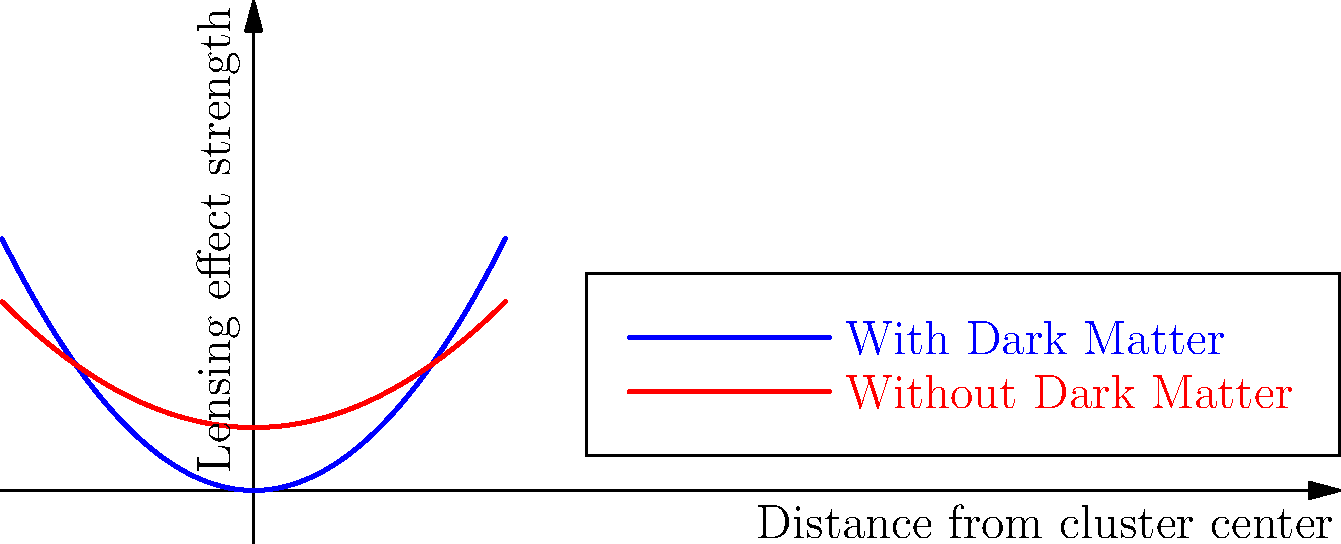Based on the graph showing gravitational lensing effects in galaxy clusters with and without dark matter assumptions, which model predicts a stronger lensing effect at greater distances from the cluster center, and how does this challenge the conventional dark matter paradigm? To answer this question, let's analyze the graph step-by-step:

1. The blue curve represents the lensing effect with dark matter assumptions, while the red curve represents the effect without dark matter.

2. Both curves show an increase in lensing effect strength as we move away from the cluster center (x-axis).

3. The blue curve (with dark matter) shows a steeper increase compared to the red curve (without dark matter).

4. At greater distances from the cluster center, the blue curve predicts a stronger lensing effect than the red curve.

5. This observation aligns with the conventional dark matter paradigm, which suggests that dark matter contributes significantly to the total mass of galaxy clusters, thereby enhancing gravitational lensing effects.

6. However, the presence of a lensing effect in the model without dark matter (red curve) challenges the notion that dark matter is necessary to explain gravitational lensing in galaxy clusters.

7. The red curve suggests that alternative theories or modifications to gravity might explain observed lensing effects without invoking dark matter.

8. The difference between the two curves is not as dramatic as one might expect if dark matter were the dominant factor in gravitational lensing.

This graph challenges the conventional dark matter paradigm by showing that:
a) Lensing effects can be observed without dark matter assumptions.
b) The difference in lensing strength between models with and without dark matter is less pronounced than expected.
c) Alternative explanations for gravitational lensing effects in galaxy clusters may be viable.
Answer: The dark matter model predicts stronger lensing at greater distances, but the presence of lensing without dark matter and the relatively small difference between models challenge dark matter's presumed dominance in this phenomenon. 